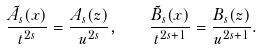Convert formula to latex. <formula><loc_0><loc_0><loc_500><loc_500>\frac { \tilde { A } _ { s } ( x ) } { t ^ { 2 s } } = \frac { A _ { s } ( z ) } { u ^ { 2 s } } , \quad \frac { \tilde { B } _ { s } ( x ) } { t ^ { 2 s + 1 } } = \frac { B _ { s } ( z ) } { u ^ { 2 s + 1 } } .</formula> 